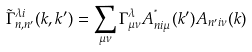<formula> <loc_0><loc_0><loc_500><loc_500>\tilde { \Gamma } ^ { \lambda i } _ { n , n ^ { \prime } } ( k , k ^ { \prime } ) = \sum _ { \mu \nu } \Gamma ^ { \lambda } _ { \mu \nu } A ^ { ^ { * } } _ { n i \mu } ( k ^ { \prime } ) A _ { n ^ { \prime } i \nu } ( k )</formula> 